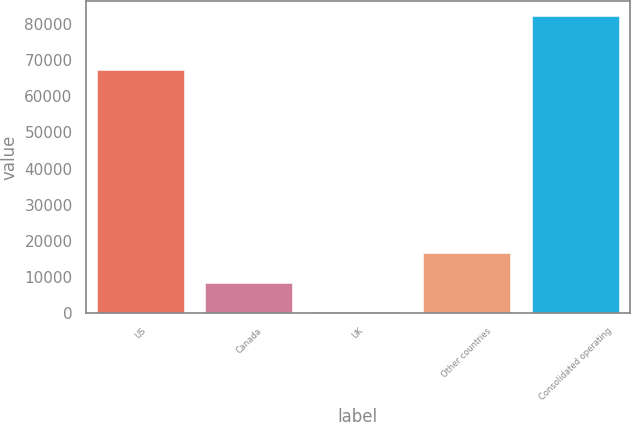<chart> <loc_0><loc_0><loc_500><loc_500><bar_chart><fcel>US<fcel>Canada<fcel>UK<fcel>Other countries<fcel>Consolidated operating<nl><fcel>67392<fcel>8357.4<fcel>149<fcel>16565.8<fcel>82233<nl></chart> 